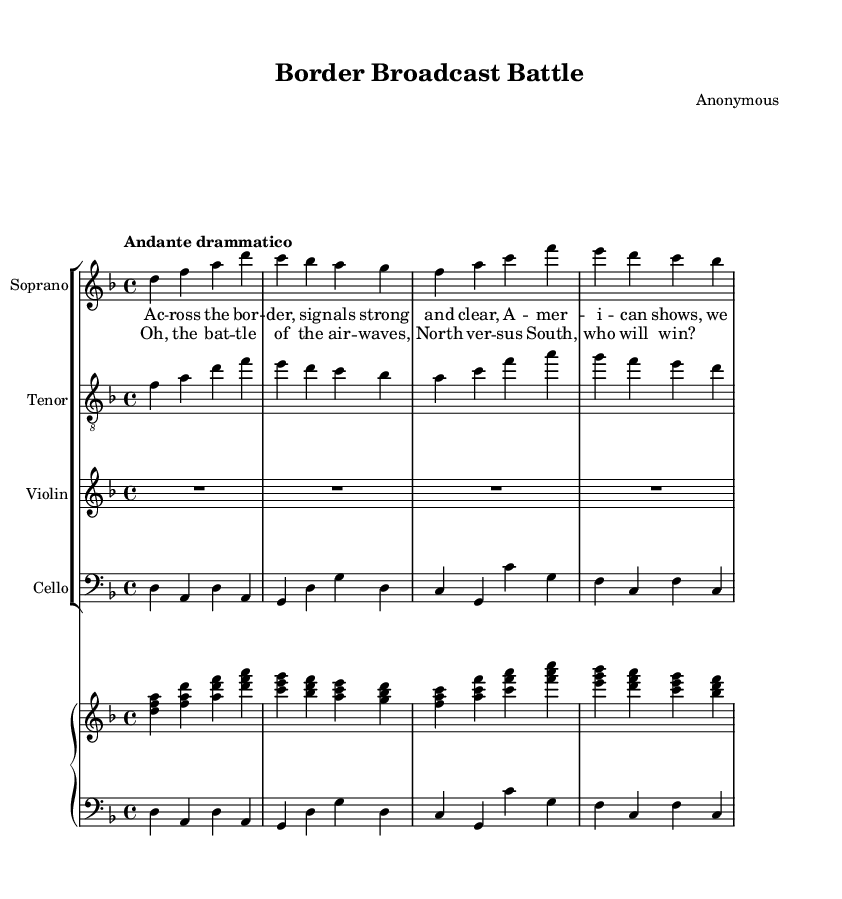What is the key signature of this music? The key signature is indicated at the beginning of the staff. In this case, it shows two flats (B♭ and E♭), which corresponds to the key of D minor.
Answer: D minor What is the time signature of this music? The time signature is indicated at the beginning of the sheet music, and it shows 4 over 4, meaning there are four beats in each measure and the quarter note gets one beat.
Answer: 4/4 What is the tempo marking in this music? The tempo marking is noted above the staff and describes the speed of the piece. Here, it is marked as "Andante drammatico," which indicates a moderately slow tempo with a dramatic character.
Answer: Andante drammatico How many staves are used in this composition? By looking at the layout of the music, we can see there are a total of six staves: one for the soprano, one for the tenor, one for the violin, one for the cello, and two for the piano (right and left hands).
Answer: Six What is the primary theme of the first verse? By reading the lyrics provided in the verse, we understand that the theme revolves around the strong signals and affection for American shows by Canadians watching from across the border.
Answer: American shows How does the chorus convey the main conflict in this opera? The chorus expresses a clear rivalry between Canada and America by stating "the battle of the airwaves," implying a competition for television viewership and popularity. This reflects the overall theme of rivalry.
Answer: North versus South Which instruments are featured in this opera arrangement? The instruments indicated in the score include a soprano voice, a tenor voice, a violin, a cello, and piano for both right and left hands. Each part is clearly labeled in the music sheet.
Answer: Soprano, Tenor, Violin, Cello, Piano 